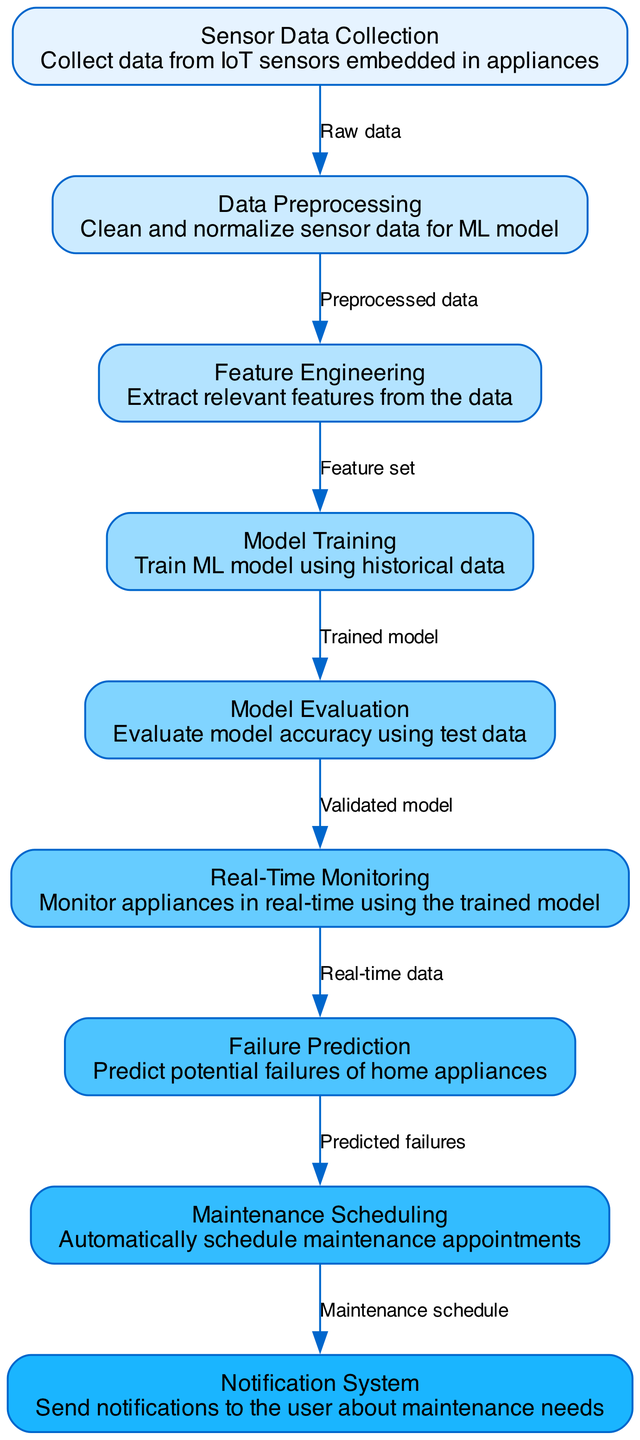What is the first node in the diagram? The first node is "Sensor Data Collection", which collects data from IoT sensors embedded in appliances.
Answer: Sensor Data Collection How many nodes are there in the diagram? By counting the nodes listed in the data, there are a total of nine nodes in the diagram.
Answer: 9 What type of data is passed from "Data Preprocessing" to "Feature Engineering"? The type of data passed is "Preprocessed data", which is the cleaned and normalized data ready for feature extraction.
Answer: Preprocessed data What is the last step in the predictive maintenance process? The last step is "Notification System", where users are notified about maintenance needs based on the scheduled maintenance.
Answer: Notification System Which two nodes are directly connected by the edge labeled "Raw data"? The nodes connected by the edge labeled "Raw data" are "Sensor Data Collection" and "Data Preprocessing".
Answer: Sensor Data Collection and Data Preprocessing What does the "Real-Time Monitoring" node utilize from "Model Evaluation"? The "Real-Time Monitoring" node utilizes the "Validated model" from "Model Evaluation" to monitor appliances.
Answer: Validated model Which node comes after "Failure Prediction" in the flow? The node that comes after "Failure Prediction" is "Maintenance Scheduling", which manages the maintenance appointments based on predicted failures.
Answer: Maintenance Scheduling How many edges are present in the diagram? There are a total of eight edges connecting the various nodes in the diagram.
Answer: 8 What is the purpose of the "Model Evaluation" node? The purpose of the "Model Evaluation" node is to evaluate the model's accuracy using test data before it proceeds to real-time monitoring.
Answer: Evaluate model accuracy using test data 